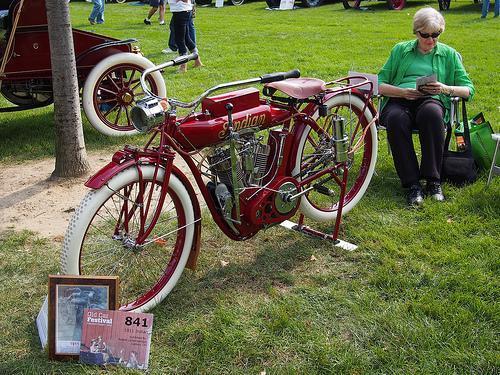How many bikes are in the photo?
Give a very brief answer. 1. 